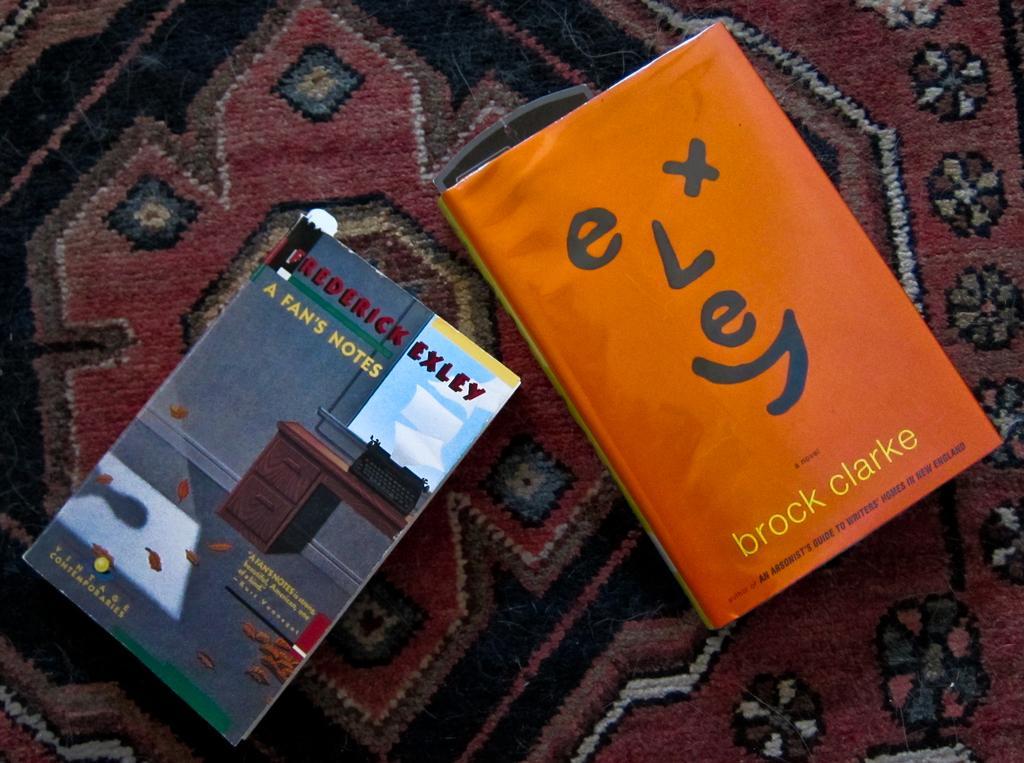Can you describe this image briefly? Here I can see two books on a bed sheet. 